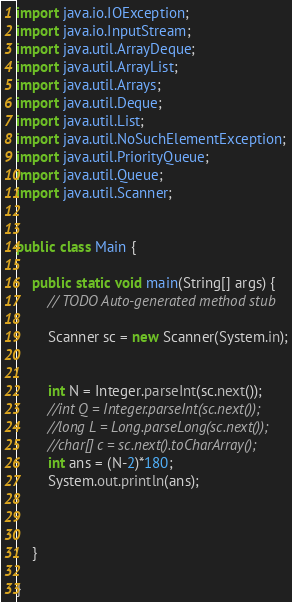Convert code to text. <code><loc_0><loc_0><loc_500><loc_500><_Java_>import java.io.IOException;
import java.io.InputStream;
import java.util.ArrayDeque;
import java.util.ArrayList;
import java.util.Arrays;
import java.util.Deque;
import java.util.List;
import java.util.NoSuchElementException;
import java.util.PriorityQueue;
import java.util.Queue;
import java.util.Scanner;
 
 
public class Main {
	
	public static void main(String[] args) {
		// TODO Auto-generated method stub
		
		Scanner sc = new Scanner(System.in);
		
		
		int N = Integer.parseInt(sc.next());
		//int Q = Integer.parseInt(sc.next());
		//long L = Long.parseLong(sc.next());
		//char[] c = sc.next().toCharArray();
		int ans = (N-2)*180;		
		System.out.println(ans);
		
		
		
	}
	
}

</code> 